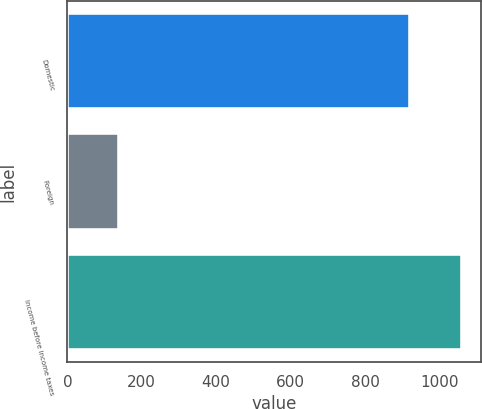<chart> <loc_0><loc_0><loc_500><loc_500><bar_chart><fcel>Domestic<fcel>Foreign<fcel>Income before income taxes<nl><fcel>922<fcel>138<fcel>1060<nl></chart> 